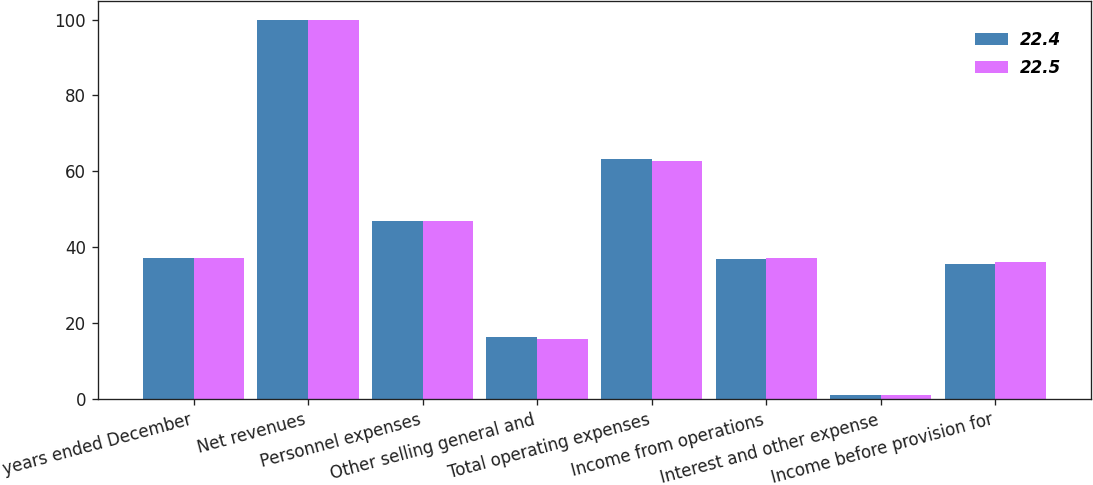Convert chart to OTSL. <chart><loc_0><loc_0><loc_500><loc_500><stacked_bar_chart><ecel><fcel>For the years ended December<fcel>Net revenues<fcel>Personnel expenses<fcel>Other selling general and<fcel>Total operating expenses<fcel>Income from operations<fcel>Interest and other expense<fcel>Income before provision for<nl><fcel>22.4<fcel>37.05<fcel>100<fcel>46.8<fcel>16.4<fcel>63.2<fcel>36.8<fcel>1.1<fcel>35.7<nl><fcel>22.5<fcel>37.05<fcel>100<fcel>46.8<fcel>15.9<fcel>62.7<fcel>37.3<fcel>1.2<fcel>36<nl></chart> 